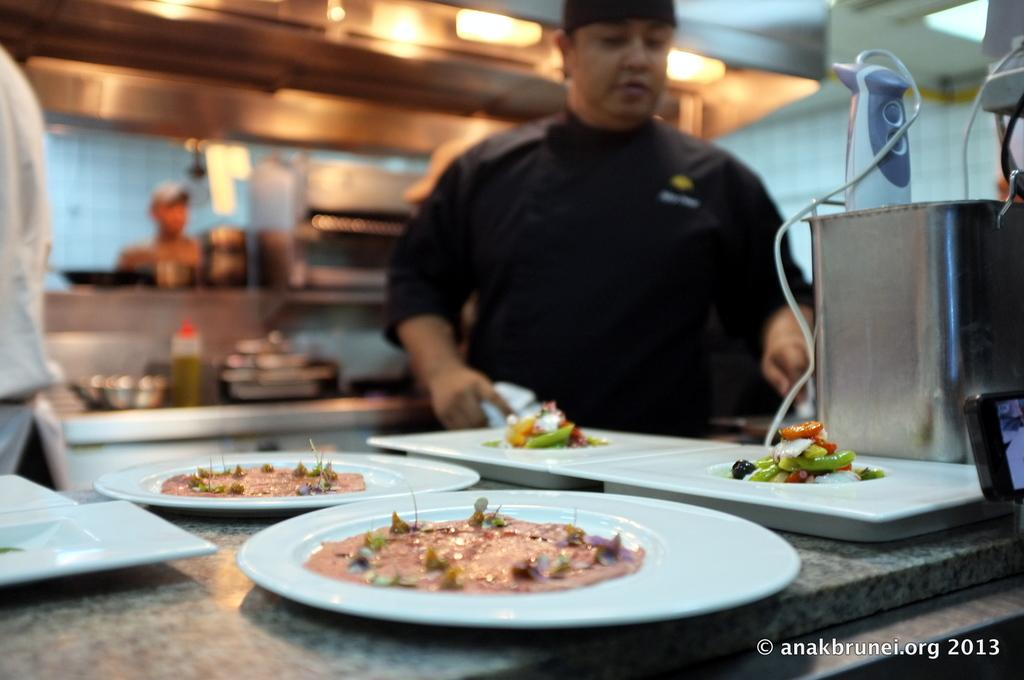What is the main subject in the image? There is a man standing in the image. What can be seen on the table in the image? Plates, a tray, and food are visible on the table in the image. What might be used to serve or carry food in the image? A tray is present on the table in the image. What is the condition of the background in the image? The background of the image is blurred. Can you see any rays of sunlight shining through the umbrella in the image? There is no umbrella present in the image, and therefore no rays of sunlight shining through it. 